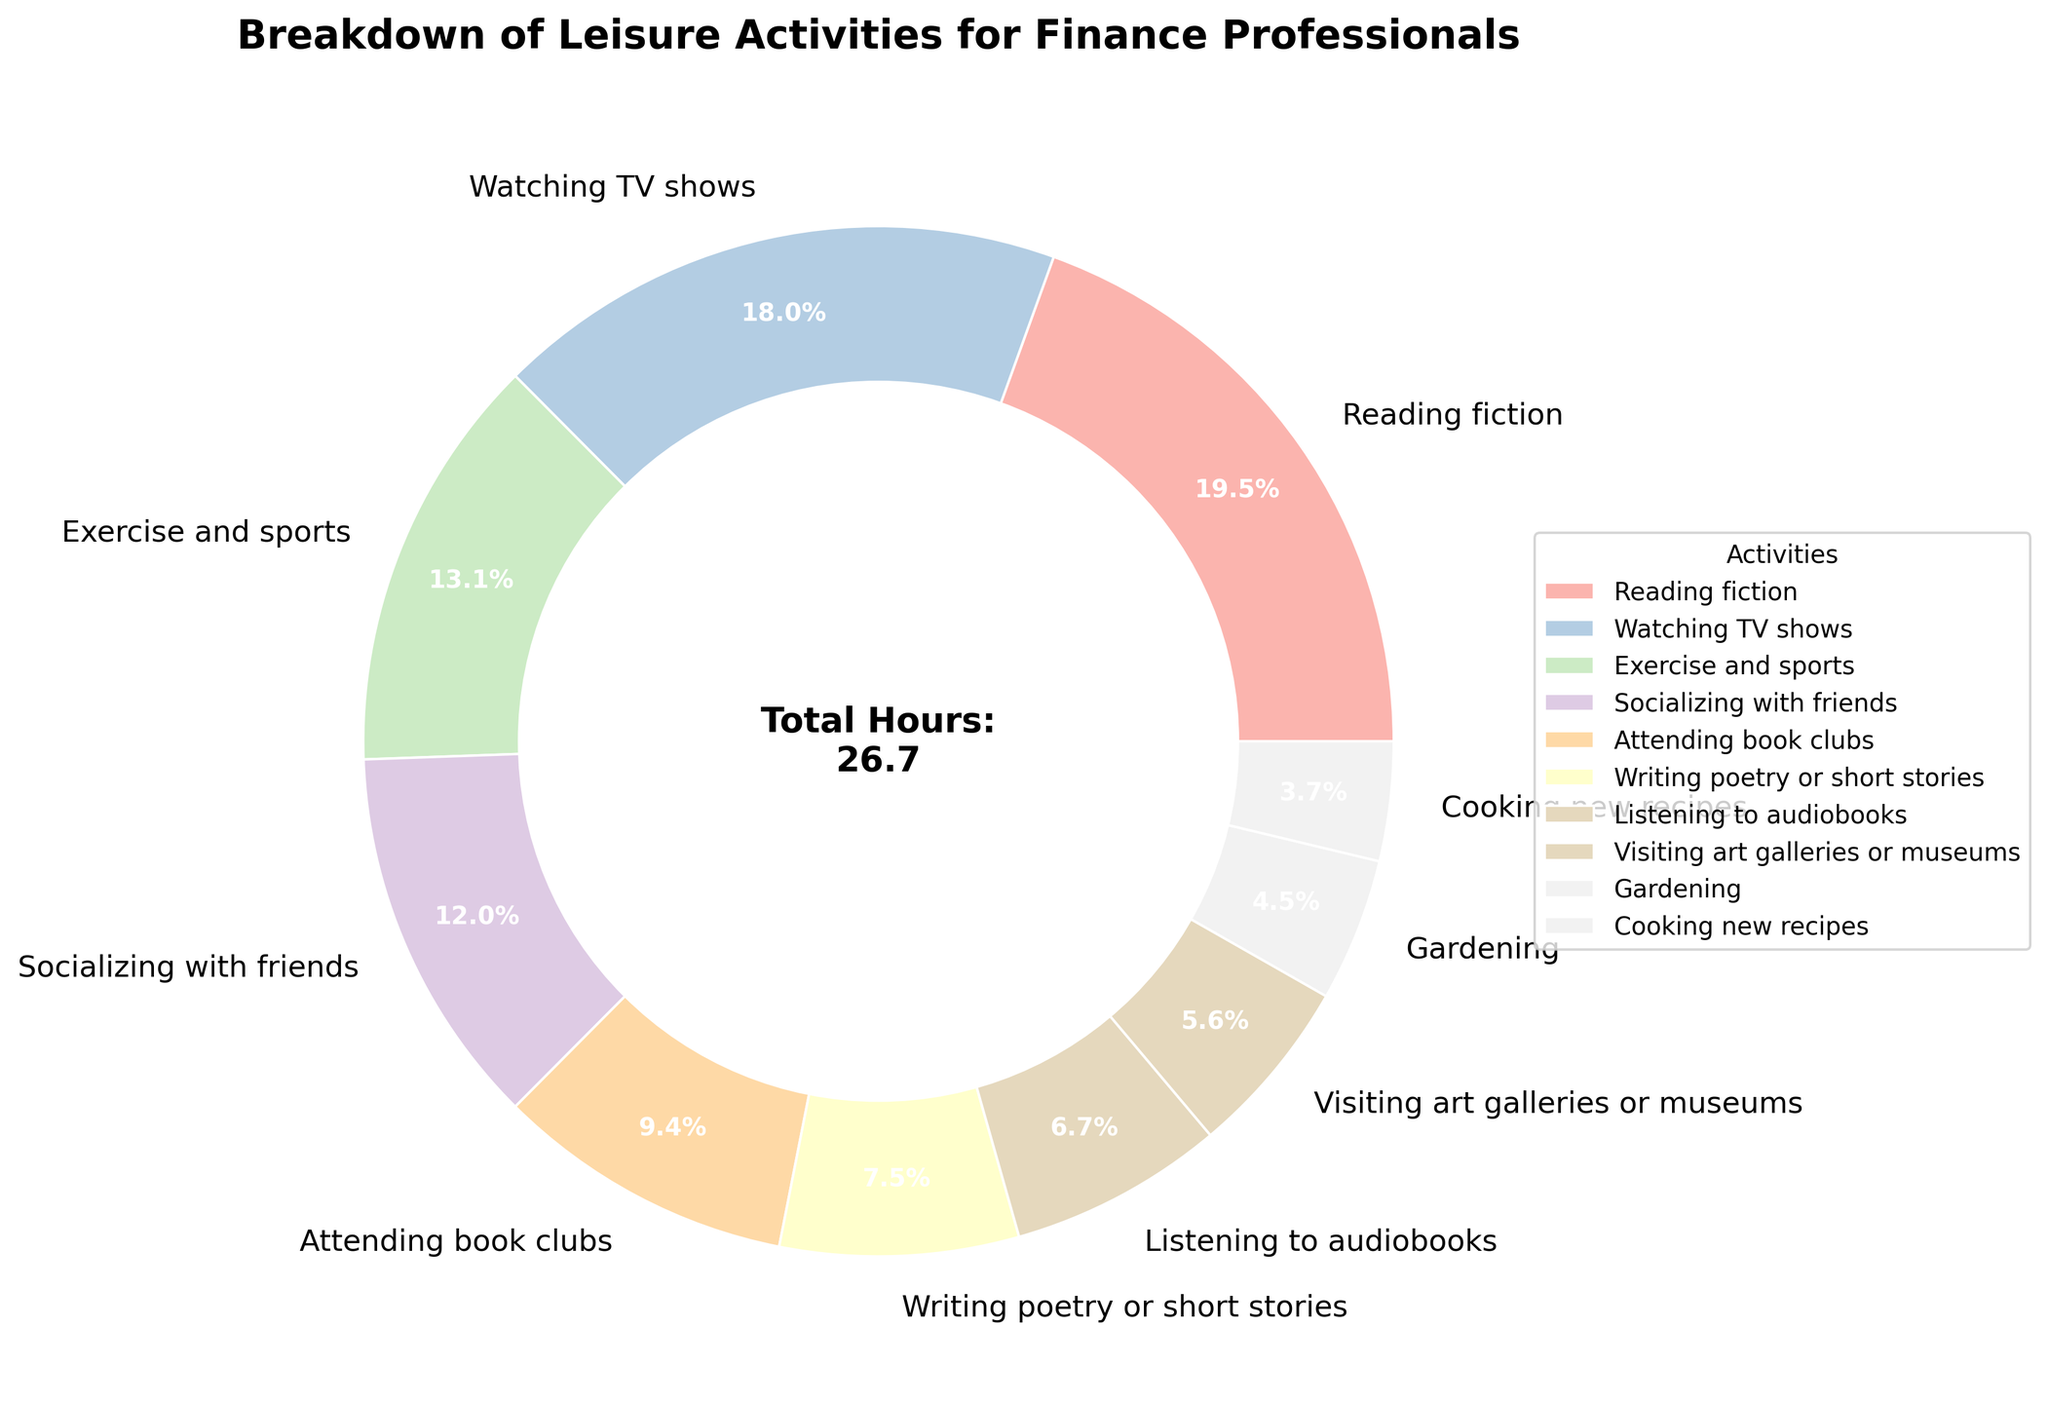What percentage of time is spent on Reading fiction? The pie chart shows the breakdown of different activities as percentages. Locate the section labeled "Reading fiction" and read its percentage.
Answer: 16.5% Which two activities together take up more time: Watching TV shows and Gardening, or Exercise and sports and Writing poetry or short stories? First, sum the hours for Watching TV shows (4.8) and Gardening (1.2): 4.8 + 1.2 = 6. 
Then, sum the hours for Exercise and sports (3.5) and Writing poetry or short stories (2.0): 3.5 + 2.0 = 5.5. 
Compare the two sums: 6 > 5.5.
Answer: Watching TV shows and Gardening How many more hours per week are spent on Socializing with friends than on Cooking new recipes? Locate the hours for Socializing with friends (3.2) and Cooking new recipes (1.0). Subtract the hours for Cooking new recipes from those for Socializing with friends: 3.2 - 1.0 = 2.2.
Answer: 2.2 hours Which activity has the smallest percentage of time spent, and what is that percentage? Look for the smallest wedge in the pie chart. According to the labels, Cooking new recipes has the smallest percentage, which is shown as a percentage on the figure.
Answer: Cooking new recipes, 3.1% What is the total time spent per week on activities involving literature (Reading fiction, Attending book clubs, Writing poetry or short stories, Listening to audiobooks)? Sum the hours for the listed activities: Reading fiction (5.2), Attending book clubs (2.5), Writing poetry or short stories (2.0), Listening to audiobooks (1.8). 5.2 + 2.5 + 2.0 + 1.8 = 11.5.
Answer: 11.5 hours How does the time spent on Exercise and sports compare to the time spent on Socializing with friends? Check the hours for Exercise and sports (3.5) and Socializing with friends (3.2). Determine which activity has more hours spent.
Answer: More time is spent on Exercise and sports What is the combined percentage of time spent on Watching TV shows and Reading fiction? Find the percentage for Watching TV shows (15.3%) and Reading fiction (16.5%) from the chart. Add these percentages: 15.3% + 16.5% = 31.8%.
Answer: 31.8% What is the total number of hours spent on the three least time-consuming activities? Identify the three activities with the smallest wedges: Gardening (1.2), Cooking new recipes (1.0), Visiting art galleries or museums (1.5). Sum their hours: 1.2 + 1.0 + 1.5 = 3.7.
Answer: 3.7 hours What percentage of time is spent on activities related to creativity (Writing poetry or short stories, Cooking new recipes, Listening to audiobooks)? Locate the percentages for the activities: Writing poetry or short stories (6.3%), Cooking new recipes (3.1%), Listening to audiobooks (5.7%). Sum these percentages: 6.3% + 3.1% + 5.7% = 15.1%.
Answer: 15.1% 